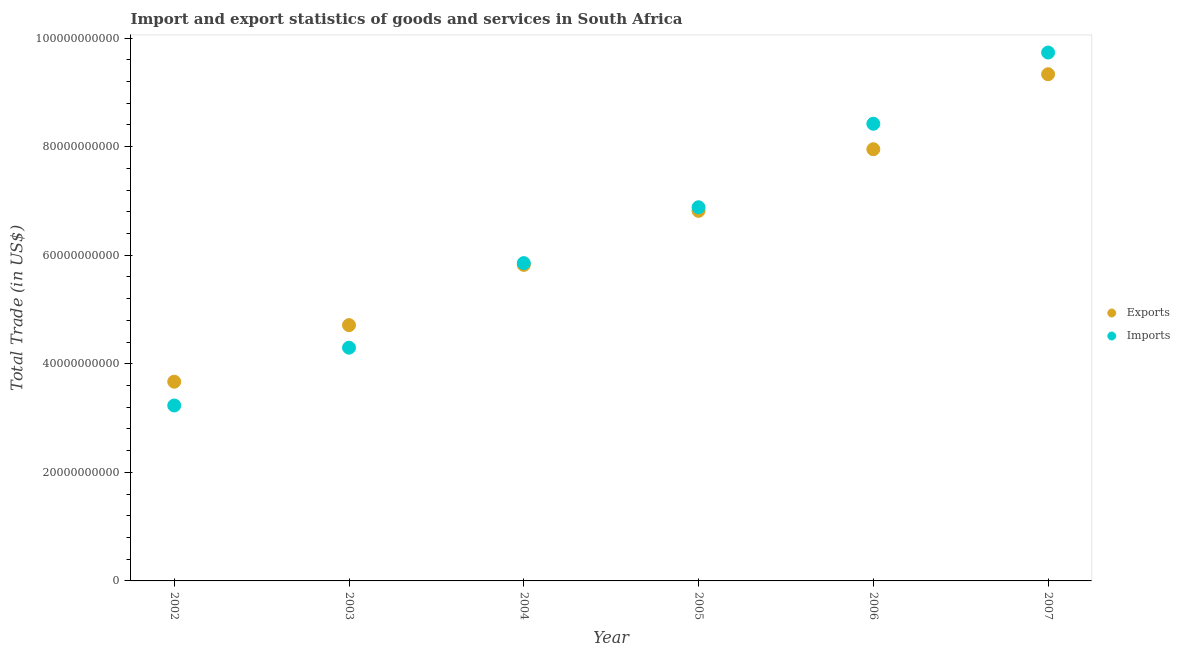What is the export of goods and services in 2007?
Your answer should be very brief. 9.33e+1. Across all years, what is the maximum imports of goods and services?
Keep it short and to the point. 9.73e+1. Across all years, what is the minimum imports of goods and services?
Your answer should be compact. 3.23e+1. What is the total export of goods and services in the graph?
Ensure brevity in your answer.  3.83e+11. What is the difference between the imports of goods and services in 2002 and that in 2004?
Your answer should be very brief. -2.62e+1. What is the difference between the imports of goods and services in 2007 and the export of goods and services in 2006?
Offer a terse response. 1.78e+1. What is the average imports of goods and services per year?
Keep it short and to the point. 6.40e+1. In the year 2002, what is the difference between the export of goods and services and imports of goods and services?
Your answer should be compact. 4.38e+09. What is the ratio of the export of goods and services in 2004 to that in 2007?
Offer a very short reply. 0.62. What is the difference between the highest and the second highest export of goods and services?
Give a very brief answer. 1.38e+1. What is the difference between the highest and the lowest imports of goods and services?
Keep it short and to the point. 6.50e+1. Does the export of goods and services monotonically increase over the years?
Your answer should be compact. Yes. Is the imports of goods and services strictly less than the export of goods and services over the years?
Provide a succinct answer. No. How many dotlines are there?
Keep it short and to the point. 2. How many years are there in the graph?
Make the answer very short. 6. Does the graph contain any zero values?
Your answer should be very brief. No. Where does the legend appear in the graph?
Provide a short and direct response. Center right. How are the legend labels stacked?
Provide a short and direct response. Vertical. What is the title of the graph?
Provide a short and direct response. Import and export statistics of goods and services in South Africa. Does "Investments" appear as one of the legend labels in the graph?
Your answer should be compact. No. What is the label or title of the X-axis?
Keep it short and to the point. Year. What is the label or title of the Y-axis?
Your answer should be compact. Total Trade (in US$). What is the Total Trade (in US$) of Exports in 2002?
Make the answer very short. 3.67e+1. What is the Total Trade (in US$) of Imports in 2002?
Your response must be concise. 3.23e+1. What is the Total Trade (in US$) of Exports in 2003?
Offer a very short reply. 4.71e+1. What is the Total Trade (in US$) of Imports in 2003?
Your answer should be very brief. 4.30e+1. What is the Total Trade (in US$) in Exports in 2004?
Offer a terse response. 5.82e+1. What is the Total Trade (in US$) of Imports in 2004?
Your answer should be compact. 5.85e+1. What is the Total Trade (in US$) of Exports in 2005?
Your answer should be very brief. 6.82e+1. What is the Total Trade (in US$) in Imports in 2005?
Provide a short and direct response. 6.88e+1. What is the Total Trade (in US$) of Exports in 2006?
Keep it short and to the point. 7.95e+1. What is the Total Trade (in US$) of Imports in 2006?
Your response must be concise. 8.42e+1. What is the Total Trade (in US$) in Exports in 2007?
Offer a terse response. 9.33e+1. What is the Total Trade (in US$) in Imports in 2007?
Offer a very short reply. 9.73e+1. Across all years, what is the maximum Total Trade (in US$) in Exports?
Your answer should be very brief. 9.33e+1. Across all years, what is the maximum Total Trade (in US$) in Imports?
Make the answer very short. 9.73e+1. Across all years, what is the minimum Total Trade (in US$) of Exports?
Provide a succinct answer. 3.67e+1. Across all years, what is the minimum Total Trade (in US$) in Imports?
Give a very brief answer. 3.23e+1. What is the total Total Trade (in US$) of Exports in the graph?
Keep it short and to the point. 3.83e+11. What is the total Total Trade (in US$) of Imports in the graph?
Provide a succinct answer. 3.84e+11. What is the difference between the Total Trade (in US$) in Exports in 2002 and that in 2003?
Ensure brevity in your answer.  -1.04e+1. What is the difference between the Total Trade (in US$) of Imports in 2002 and that in 2003?
Make the answer very short. -1.07e+1. What is the difference between the Total Trade (in US$) of Exports in 2002 and that in 2004?
Keep it short and to the point. -2.15e+1. What is the difference between the Total Trade (in US$) of Imports in 2002 and that in 2004?
Ensure brevity in your answer.  -2.62e+1. What is the difference between the Total Trade (in US$) in Exports in 2002 and that in 2005?
Your answer should be very brief. -3.15e+1. What is the difference between the Total Trade (in US$) of Imports in 2002 and that in 2005?
Offer a very short reply. -3.65e+1. What is the difference between the Total Trade (in US$) of Exports in 2002 and that in 2006?
Your response must be concise. -4.28e+1. What is the difference between the Total Trade (in US$) of Imports in 2002 and that in 2006?
Keep it short and to the point. -5.19e+1. What is the difference between the Total Trade (in US$) of Exports in 2002 and that in 2007?
Offer a terse response. -5.66e+1. What is the difference between the Total Trade (in US$) of Imports in 2002 and that in 2007?
Your response must be concise. -6.50e+1. What is the difference between the Total Trade (in US$) of Exports in 2003 and that in 2004?
Offer a very short reply. -1.11e+1. What is the difference between the Total Trade (in US$) of Imports in 2003 and that in 2004?
Provide a succinct answer. -1.56e+1. What is the difference between the Total Trade (in US$) in Exports in 2003 and that in 2005?
Offer a terse response. -2.11e+1. What is the difference between the Total Trade (in US$) in Imports in 2003 and that in 2005?
Your answer should be very brief. -2.59e+1. What is the difference between the Total Trade (in US$) of Exports in 2003 and that in 2006?
Provide a succinct answer. -3.24e+1. What is the difference between the Total Trade (in US$) in Imports in 2003 and that in 2006?
Keep it short and to the point. -4.12e+1. What is the difference between the Total Trade (in US$) of Exports in 2003 and that in 2007?
Make the answer very short. -4.62e+1. What is the difference between the Total Trade (in US$) of Imports in 2003 and that in 2007?
Make the answer very short. -5.44e+1. What is the difference between the Total Trade (in US$) of Exports in 2004 and that in 2005?
Provide a short and direct response. -9.96e+09. What is the difference between the Total Trade (in US$) in Imports in 2004 and that in 2005?
Provide a succinct answer. -1.03e+1. What is the difference between the Total Trade (in US$) of Exports in 2004 and that in 2006?
Provide a short and direct response. -2.13e+1. What is the difference between the Total Trade (in US$) of Imports in 2004 and that in 2006?
Your answer should be very brief. -2.57e+1. What is the difference between the Total Trade (in US$) of Exports in 2004 and that in 2007?
Offer a very short reply. -3.51e+1. What is the difference between the Total Trade (in US$) of Imports in 2004 and that in 2007?
Your answer should be compact. -3.88e+1. What is the difference between the Total Trade (in US$) of Exports in 2005 and that in 2006?
Your answer should be compact. -1.13e+1. What is the difference between the Total Trade (in US$) of Imports in 2005 and that in 2006?
Make the answer very short. -1.54e+1. What is the difference between the Total Trade (in US$) of Exports in 2005 and that in 2007?
Make the answer very short. -2.52e+1. What is the difference between the Total Trade (in US$) of Imports in 2005 and that in 2007?
Make the answer very short. -2.85e+1. What is the difference between the Total Trade (in US$) in Exports in 2006 and that in 2007?
Keep it short and to the point. -1.38e+1. What is the difference between the Total Trade (in US$) in Imports in 2006 and that in 2007?
Provide a succinct answer. -1.31e+1. What is the difference between the Total Trade (in US$) of Exports in 2002 and the Total Trade (in US$) of Imports in 2003?
Ensure brevity in your answer.  -6.27e+09. What is the difference between the Total Trade (in US$) of Exports in 2002 and the Total Trade (in US$) of Imports in 2004?
Ensure brevity in your answer.  -2.18e+1. What is the difference between the Total Trade (in US$) of Exports in 2002 and the Total Trade (in US$) of Imports in 2005?
Keep it short and to the point. -3.21e+1. What is the difference between the Total Trade (in US$) of Exports in 2002 and the Total Trade (in US$) of Imports in 2006?
Your response must be concise. -4.75e+1. What is the difference between the Total Trade (in US$) of Exports in 2002 and the Total Trade (in US$) of Imports in 2007?
Keep it short and to the point. -6.06e+1. What is the difference between the Total Trade (in US$) in Exports in 2003 and the Total Trade (in US$) in Imports in 2004?
Your response must be concise. -1.14e+1. What is the difference between the Total Trade (in US$) of Exports in 2003 and the Total Trade (in US$) of Imports in 2005?
Provide a succinct answer. -2.17e+1. What is the difference between the Total Trade (in US$) in Exports in 2003 and the Total Trade (in US$) in Imports in 2006?
Ensure brevity in your answer.  -3.71e+1. What is the difference between the Total Trade (in US$) of Exports in 2003 and the Total Trade (in US$) of Imports in 2007?
Your answer should be compact. -5.02e+1. What is the difference between the Total Trade (in US$) in Exports in 2004 and the Total Trade (in US$) in Imports in 2005?
Give a very brief answer. -1.06e+1. What is the difference between the Total Trade (in US$) of Exports in 2004 and the Total Trade (in US$) of Imports in 2006?
Offer a very short reply. -2.60e+1. What is the difference between the Total Trade (in US$) of Exports in 2004 and the Total Trade (in US$) of Imports in 2007?
Offer a very short reply. -3.91e+1. What is the difference between the Total Trade (in US$) of Exports in 2005 and the Total Trade (in US$) of Imports in 2006?
Provide a succinct answer. -1.60e+1. What is the difference between the Total Trade (in US$) of Exports in 2005 and the Total Trade (in US$) of Imports in 2007?
Offer a terse response. -2.92e+1. What is the difference between the Total Trade (in US$) of Exports in 2006 and the Total Trade (in US$) of Imports in 2007?
Offer a terse response. -1.78e+1. What is the average Total Trade (in US$) of Exports per year?
Your answer should be very brief. 6.38e+1. What is the average Total Trade (in US$) in Imports per year?
Offer a very short reply. 6.40e+1. In the year 2002, what is the difference between the Total Trade (in US$) in Exports and Total Trade (in US$) in Imports?
Offer a terse response. 4.38e+09. In the year 2003, what is the difference between the Total Trade (in US$) of Exports and Total Trade (in US$) of Imports?
Make the answer very short. 4.15e+09. In the year 2004, what is the difference between the Total Trade (in US$) in Exports and Total Trade (in US$) in Imports?
Your response must be concise. -3.29e+08. In the year 2005, what is the difference between the Total Trade (in US$) of Exports and Total Trade (in US$) of Imports?
Make the answer very short. -6.59e+08. In the year 2006, what is the difference between the Total Trade (in US$) in Exports and Total Trade (in US$) in Imports?
Keep it short and to the point. -4.70e+09. In the year 2007, what is the difference between the Total Trade (in US$) of Exports and Total Trade (in US$) of Imports?
Offer a very short reply. -4.00e+09. What is the ratio of the Total Trade (in US$) of Exports in 2002 to that in 2003?
Your answer should be compact. 0.78. What is the ratio of the Total Trade (in US$) in Imports in 2002 to that in 2003?
Offer a terse response. 0.75. What is the ratio of the Total Trade (in US$) of Exports in 2002 to that in 2004?
Your answer should be compact. 0.63. What is the ratio of the Total Trade (in US$) of Imports in 2002 to that in 2004?
Keep it short and to the point. 0.55. What is the ratio of the Total Trade (in US$) in Exports in 2002 to that in 2005?
Keep it short and to the point. 0.54. What is the ratio of the Total Trade (in US$) of Imports in 2002 to that in 2005?
Your answer should be compact. 0.47. What is the ratio of the Total Trade (in US$) in Exports in 2002 to that in 2006?
Ensure brevity in your answer.  0.46. What is the ratio of the Total Trade (in US$) in Imports in 2002 to that in 2006?
Give a very brief answer. 0.38. What is the ratio of the Total Trade (in US$) of Exports in 2002 to that in 2007?
Your answer should be very brief. 0.39. What is the ratio of the Total Trade (in US$) of Imports in 2002 to that in 2007?
Your answer should be compact. 0.33. What is the ratio of the Total Trade (in US$) of Exports in 2003 to that in 2004?
Offer a very short reply. 0.81. What is the ratio of the Total Trade (in US$) of Imports in 2003 to that in 2004?
Your response must be concise. 0.73. What is the ratio of the Total Trade (in US$) of Exports in 2003 to that in 2005?
Give a very brief answer. 0.69. What is the ratio of the Total Trade (in US$) of Imports in 2003 to that in 2005?
Ensure brevity in your answer.  0.62. What is the ratio of the Total Trade (in US$) of Exports in 2003 to that in 2006?
Your answer should be compact. 0.59. What is the ratio of the Total Trade (in US$) of Imports in 2003 to that in 2006?
Provide a succinct answer. 0.51. What is the ratio of the Total Trade (in US$) in Exports in 2003 to that in 2007?
Your answer should be compact. 0.5. What is the ratio of the Total Trade (in US$) in Imports in 2003 to that in 2007?
Offer a terse response. 0.44. What is the ratio of the Total Trade (in US$) of Exports in 2004 to that in 2005?
Your response must be concise. 0.85. What is the ratio of the Total Trade (in US$) of Imports in 2004 to that in 2005?
Your response must be concise. 0.85. What is the ratio of the Total Trade (in US$) of Exports in 2004 to that in 2006?
Ensure brevity in your answer.  0.73. What is the ratio of the Total Trade (in US$) of Imports in 2004 to that in 2006?
Keep it short and to the point. 0.7. What is the ratio of the Total Trade (in US$) of Exports in 2004 to that in 2007?
Offer a terse response. 0.62. What is the ratio of the Total Trade (in US$) of Imports in 2004 to that in 2007?
Keep it short and to the point. 0.6. What is the ratio of the Total Trade (in US$) of Exports in 2005 to that in 2006?
Keep it short and to the point. 0.86. What is the ratio of the Total Trade (in US$) of Imports in 2005 to that in 2006?
Offer a very short reply. 0.82. What is the ratio of the Total Trade (in US$) of Exports in 2005 to that in 2007?
Give a very brief answer. 0.73. What is the ratio of the Total Trade (in US$) of Imports in 2005 to that in 2007?
Ensure brevity in your answer.  0.71. What is the ratio of the Total Trade (in US$) in Exports in 2006 to that in 2007?
Your answer should be very brief. 0.85. What is the ratio of the Total Trade (in US$) of Imports in 2006 to that in 2007?
Your response must be concise. 0.87. What is the difference between the highest and the second highest Total Trade (in US$) in Exports?
Make the answer very short. 1.38e+1. What is the difference between the highest and the second highest Total Trade (in US$) in Imports?
Your response must be concise. 1.31e+1. What is the difference between the highest and the lowest Total Trade (in US$) of Exports?
Offer a very short reply. 5.66e+1. What is the difference between the highest and the lowest Total Trade (in US$) in Imports?
Provide a succinct answer. 6.50e+1. 